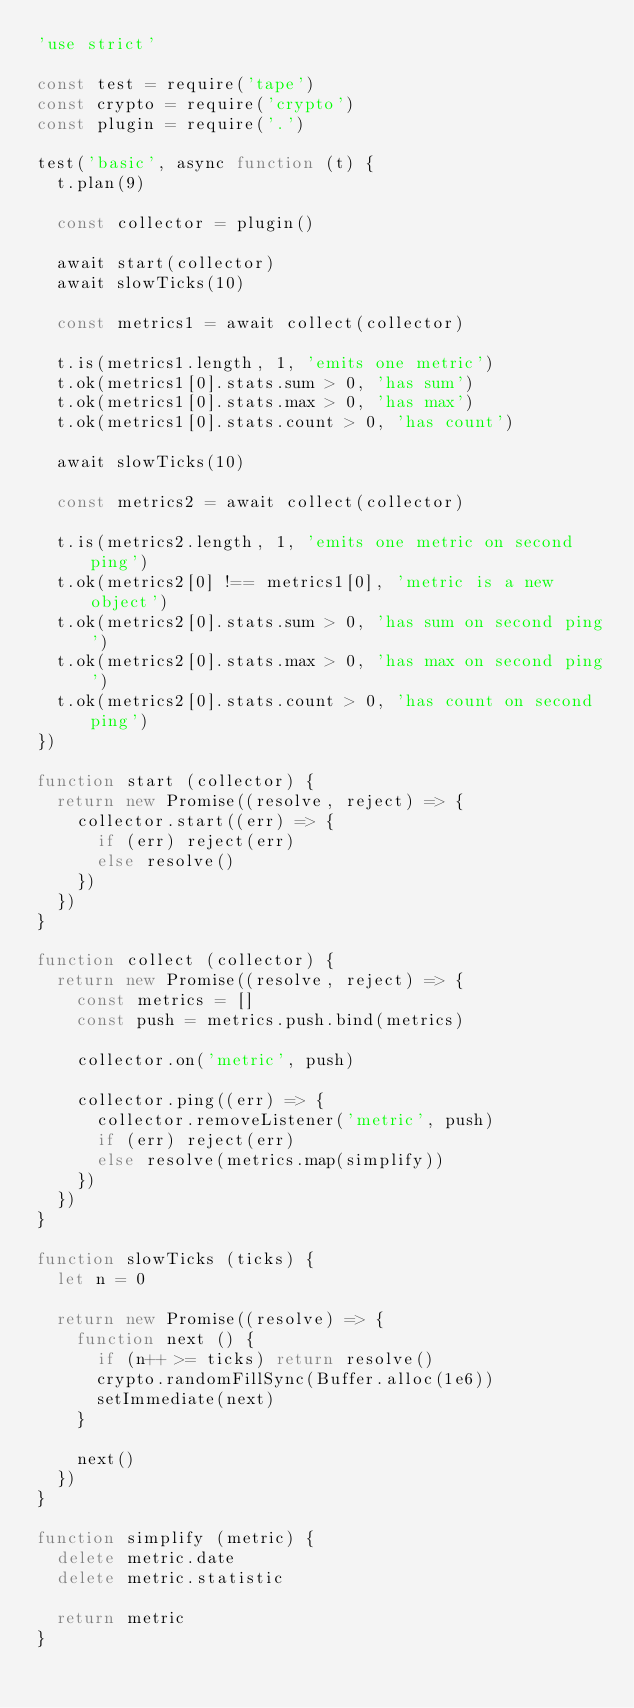Convert code to text. <code><loc_0><loc_0><loc_500><loc_500><_JavaScript_>'use strict'

const test = require('tape')
const crypto = require('crypto')
const plugin = require('.')

test('basic', async function (t) {
  t.plan(9)

  const collector = plugin()

  await start(collector)
  await slowTicks(10)

  const metrics1 = await collect(collector)

  t.is(metrics1.length, 1, 'emits one metric')
  t.ok(metrics1[0].stats.sum > 0, 'has sum')
  t.ok(metrics1[0].stats.max > 0, 'has max')
  t.ok(metrics1[0].stats.count > 0, 'has count')

  await slowTicks(10)

  const metrics2 = await collect(collector)

  t.is(metrics2.length, 1, 'emits one metric on second ping')
  t.ok(metrics2[0] !== metrics1[0], 'metric is a new object')
  t.ok(metrics2[0].stats.sum > 0, 'has sum on second ping')
  t.ok(metrics2[0].stats.max > 0, 'has max on second ping')
  t.ok(metrics2[0].stats.count > 0, 'has count on second ping')
})

function start (collector) {
  return new Promise((resolve, reject) => {
    collector.start((err) => {
      if (err) reject(err)
      else resolve()
    })
  })
}

function collect (collector) {
  return new Promise((resolve, reject) => {
    const metrics = []
    const push = metrics.push.bind(metrics)

    collector.on('metric', push)

    collector.ping((err) => {
      collector.removeListener('metric', push)
      if (err) reject(err)
      else resolve(metrics.map(simplify))
    })
  })
}

function slowTicks (ticks) {
  let n = 0

  return new Promise((resolve) => {
    function next () {
      if (n++ >= ticks) return resolve()
      crypto.randomFillSync(Buffer.alloc(1e6))
      setImmediate(next)
    }

    next()
  })
}

function simplify (metric) {
  delete metric.date
  delete metric.statistic

  return metric
}
</code> 